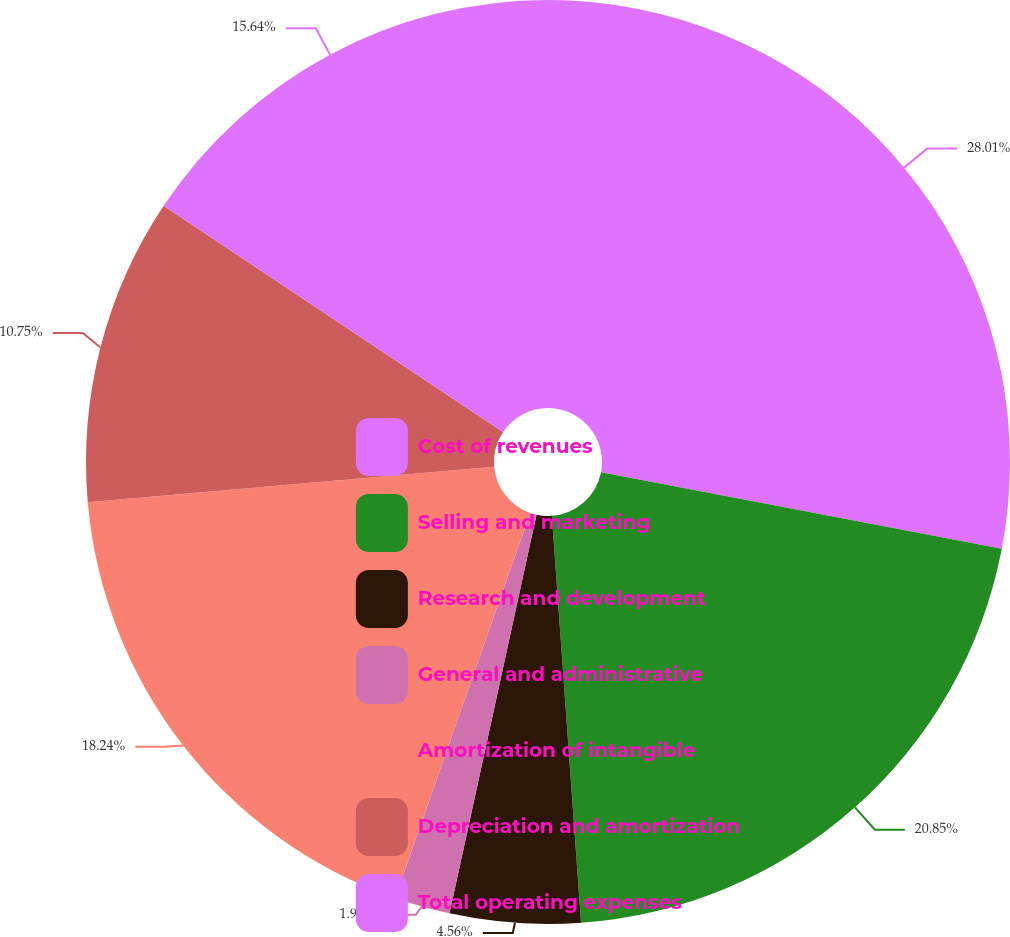<chart> <loc_0><loc_0><loc_500><loc_500><pie_chart><fcel>Cost of revenues<fcel>Selling and marketing<fcel>Research and development<fcel>General and administrative<fcel>Amortization of intangible<fcel>Depreciation and amortization<fcel>Total operating expenses<nl><fcel>28.01%<fcel>20.85%<fcel>4.56%<fcel>1.95%<fcel>18.24%<fcel>10.75%<fcel>15.64%<nl></chart> 